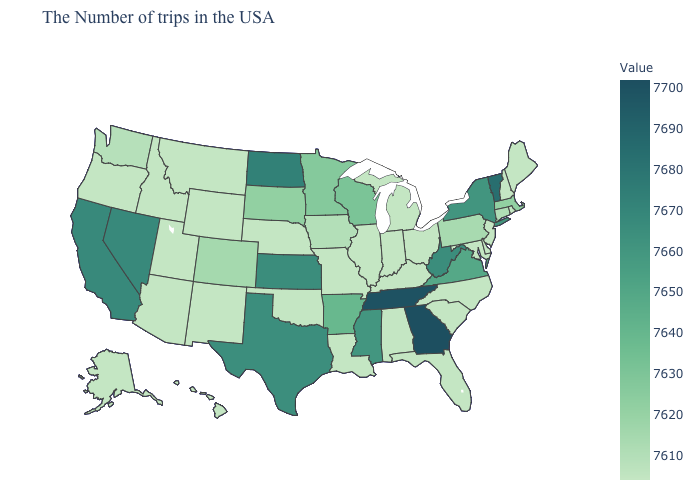Which states have the lowest value in the Northeast?
Write a very short answer. Maine, Rhode Island, New Hampshire, New Jersey. Does Georgia have the highest value in the USA?
Answer briefly. Yes. Among the states that border Arizona , does Utah have the highest value?
Short answer required. No. Among the states that border Delaware , which have the lowest value?
Concise answer only. New Jersey, Maryland. 